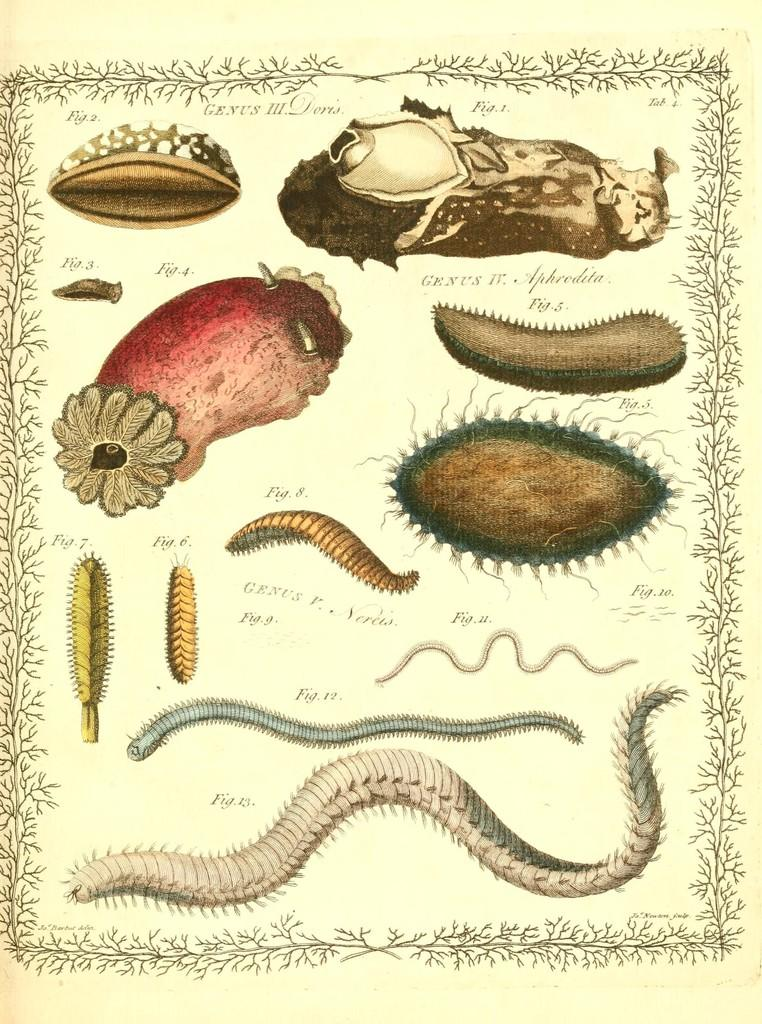What is the main subject of the painting in the image? The main subject of the painting in the image is insects. Are there any other elements in the painting besides insects? Yes, there are other things depicted in the painting. Is there any text present in the image? Yes, there is writing on the image. Can you tell me how deep the quicksand is in the image? There is no quicksand present in the image; it features a painting of insects and other elements. 